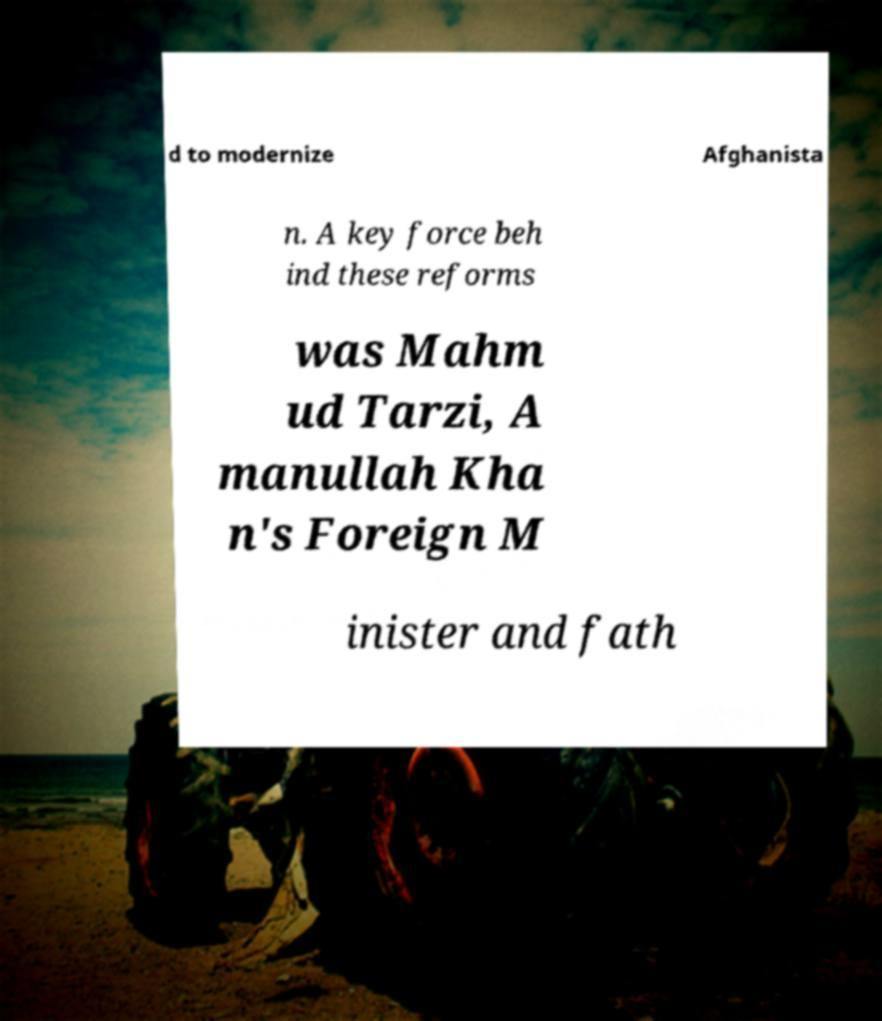Please identify and transcribe the text found in this image. d to modernize Afghanista n. A key force beh ind these reforms was Mahm ud Tarzi, A manullah Kha n's Foreign M inister and fath 